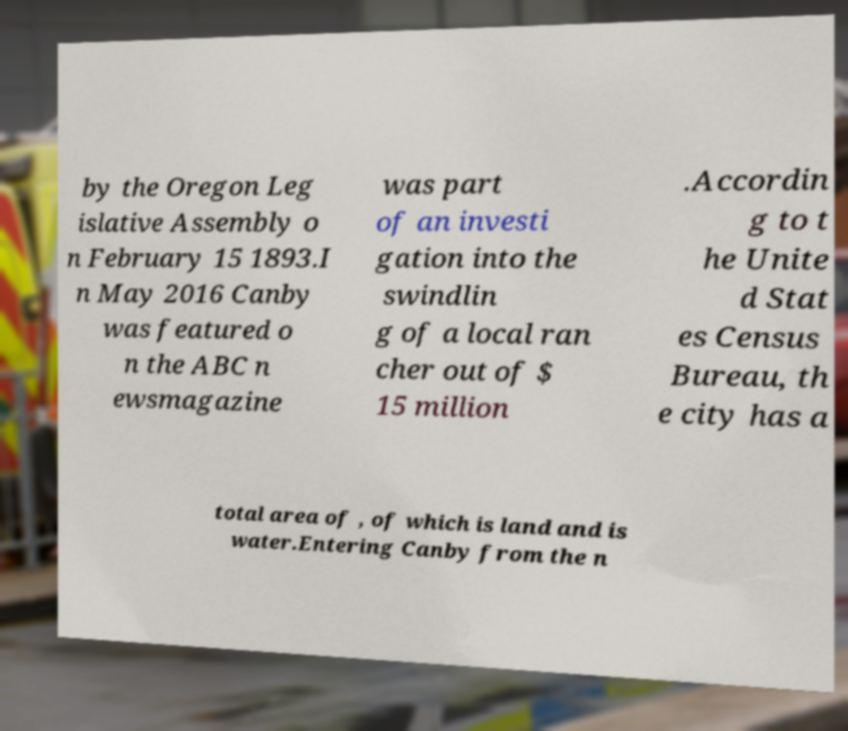Please identify and transcribe the text found in this image. by the Oregon Leg islative Assembly o n February 15 1893.I n May 2016 Canby was featured o n the ABC n ewsmagazine was part of an investi gation into the swindlin g of a local ran cher out of $ 15 million .Accordin g to t he Unite d Stat es Census Bureau, th e city has a total area of , of which is land and is water.Entering Canby from the n 